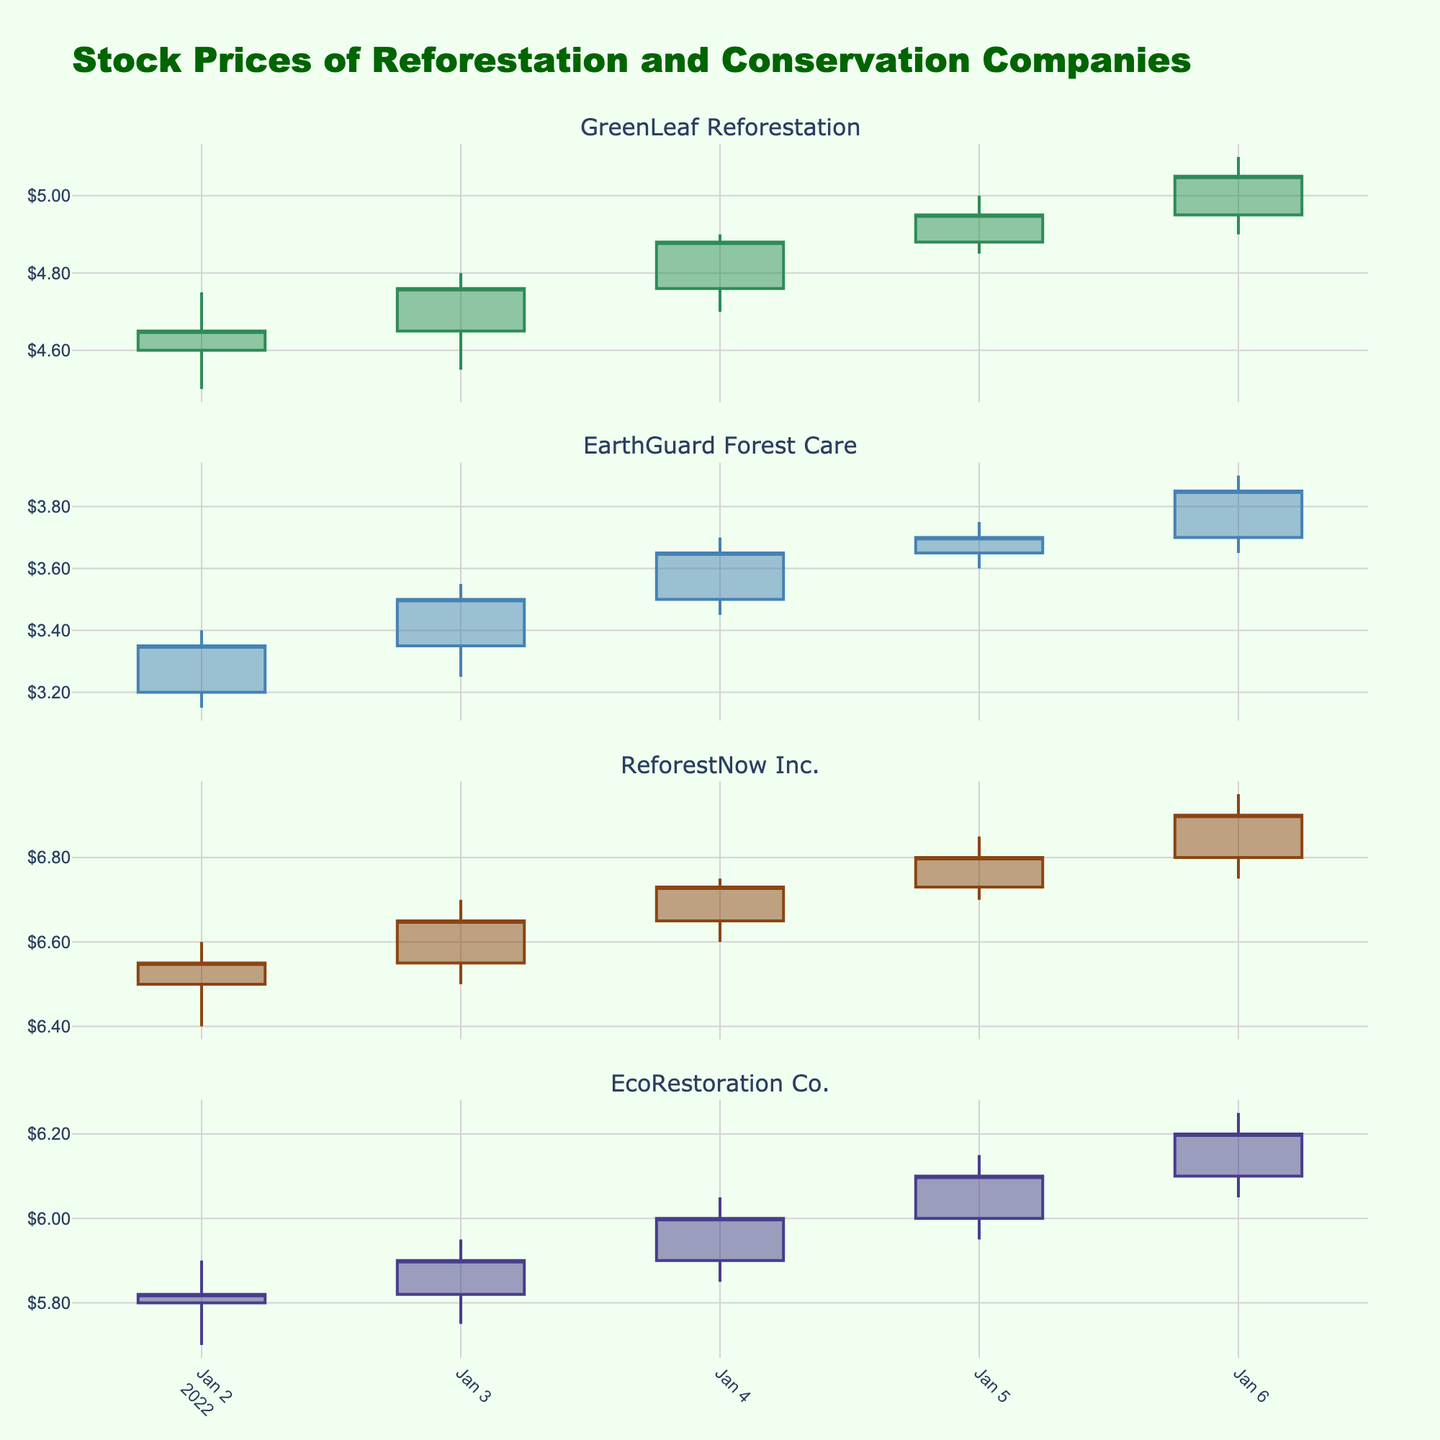What is the title of the figure? The title of the figure is provided at the top in a larger font size, indicating its importance. The text "Stock Prices of Reforestation and Conservation Companies" is clearly visible.
Answer: Stock Prices of Reforestation and Conservation Companies How many companies are represented in the figure? Each subplot represents data for an individual company, and the number of subplot titles can be counted. There are four distinct companies listed in the subplot titles.
Answer: Four Which company had the highest closing price on 2022-01-06? By examining the closing prices for the date 2022-01-06 across all four subplots, ReforestNow Inc. shows a closing price of $6.90, which is the highest.
Answer: ReforestNow Inc What is the average closing price for GreenLeaf Reforestation from 2022-01-02 to 2022-01-06? Sum the closing prices for each day for GreenLeaf Reforestation and then divide by the number of days: (4.65 + 4.76 + 4.88 + 4.95 + 5.05) / 5 = 24.29 / 5
Answer: 4.86 Which company had the greatest daily closing price increase, and on which date did it occur? Observe the differences between consecutive closing prices for each company. EcoRestoration Co. had the biggest single-day increase of $0.13 from 2022-01-04 to 2022-01-05 (6.00 to 6.10).
Answer: EcoRestoration Co., 2022-01-05 Did any company’s stock price decrease on 2022-01-06 compared to the previous day? If so, which one? By comparing the closing prices on 2022-01-06 to those on 2022-01-05, you can see that all companies had higher or the same closing prices on 2022-01-06.
Answer: No What is the total trading volume for GreenLeaf Reforestation over the period of 2022-01-02 to 2022-01-06? Sum the volume for each day for GreenLeaf Reforestation: 150000 + 175000 + 160000 + 180000 + 190000 = 855000.
Answer: 855000 Compare the trend of closing prices for EarthGuard Forest Care and EcoRestoration Co. Which one showed a more consistent upward trend? EarthGuard Forest Care shows a consistent daily increase in closing prices without any decrease: 3.35, 3.50, 3.65, 3.70, 3.85. Whereas EcoRestoration Co. follows a similar upward trend: 5.82, 5.90, 6.00, 6.10, 6.20. However, both trends are consistent without dips, with percentages approximately the same.
Answer: Both 